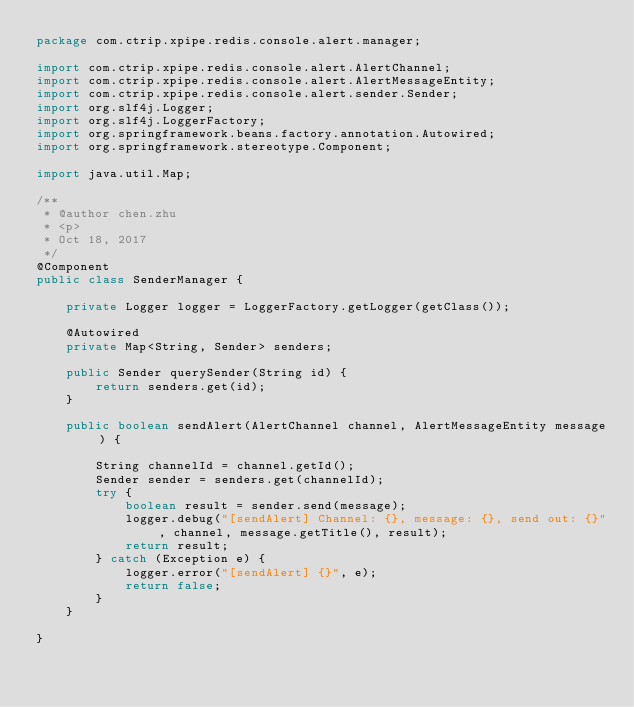<code> <loc_0><loc_0><loc_500><loc_500><_Java_>package com.ctrip.xpipe.redis.console.alert.manager;

import com.ctrip.xpipe.redis.console.alert.AlertChannel;
import com.ctrip.xpipe.redis.console.alert.AlertMessageEntity;
import com.ctrip.xpipe.redis.console.alert.sender.Sender;
import org.slf4j.Logger;
import org.slf4j.LoggerFactory;
import org.springframework.beans.factory.annotation.Autowired;
import org.springframework.stereotype.Component;

import java.util.Map;

/**
 * @author chen.zhu
 * <p>
 * Oct 18, 2017
 */
@Component
public class SenderManager {

    private Logger logger = LoggerFactory.getLogger(getClass());

    @Autowired
    private Map<String, Sender> senders;

    public Sender querySender(String id) {
        return senders.get(id);
    }

    public boolean sendAlert(AlertChannel channel, AlertMessageEntity message) {

        String channelId = channel.getId();
        Sender sender = senders.get(channelId);
        try {
            boolean result = sender.send(message);
            logger.debug("[sendAlert] Channel: {}, message: {}, send out: {}", channel, message.getTitle(), result);
            return result;
        } catch (Exception e) {
            logger.error("[sendAlert] {}", e);
            return false;
        }
    }

}
</code> 